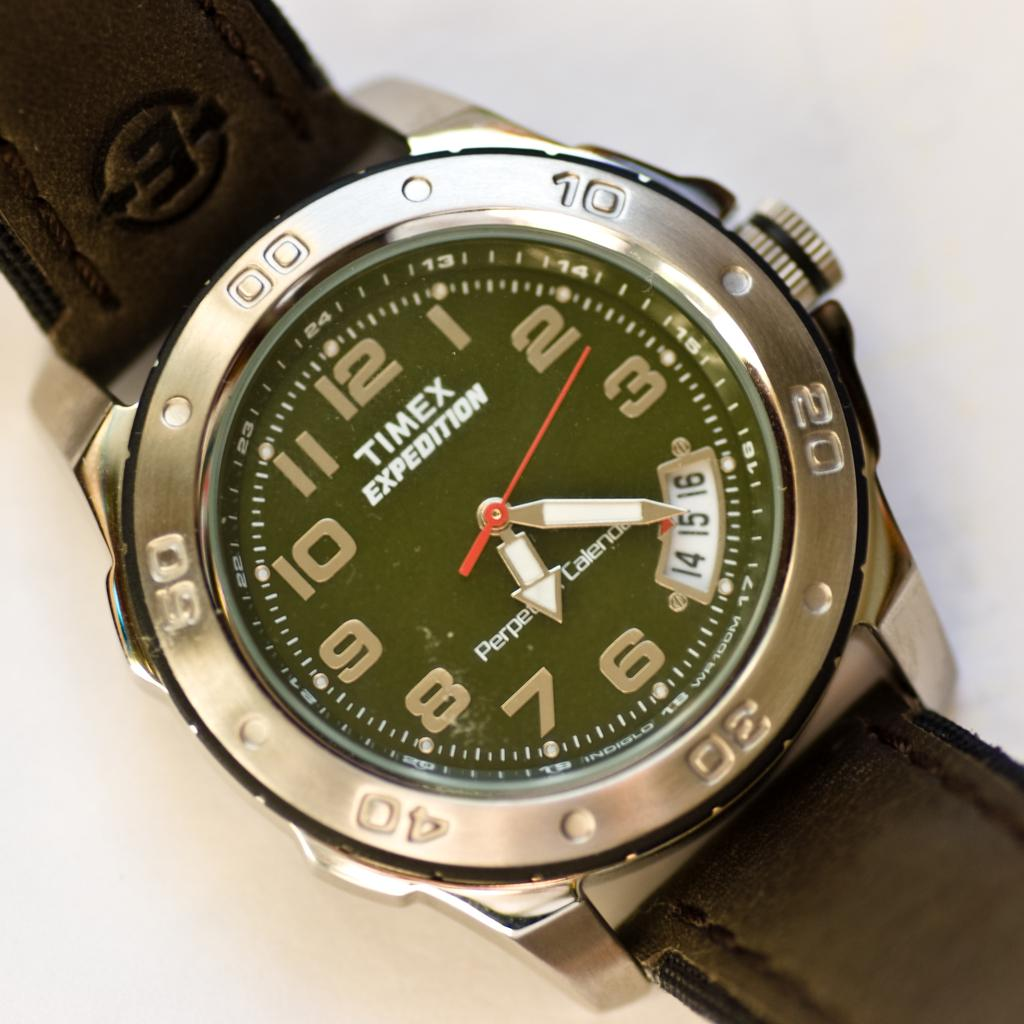Provide a one-sentence caption for the provided image. A Timex watch with a brown leather band that shows 6:20. 